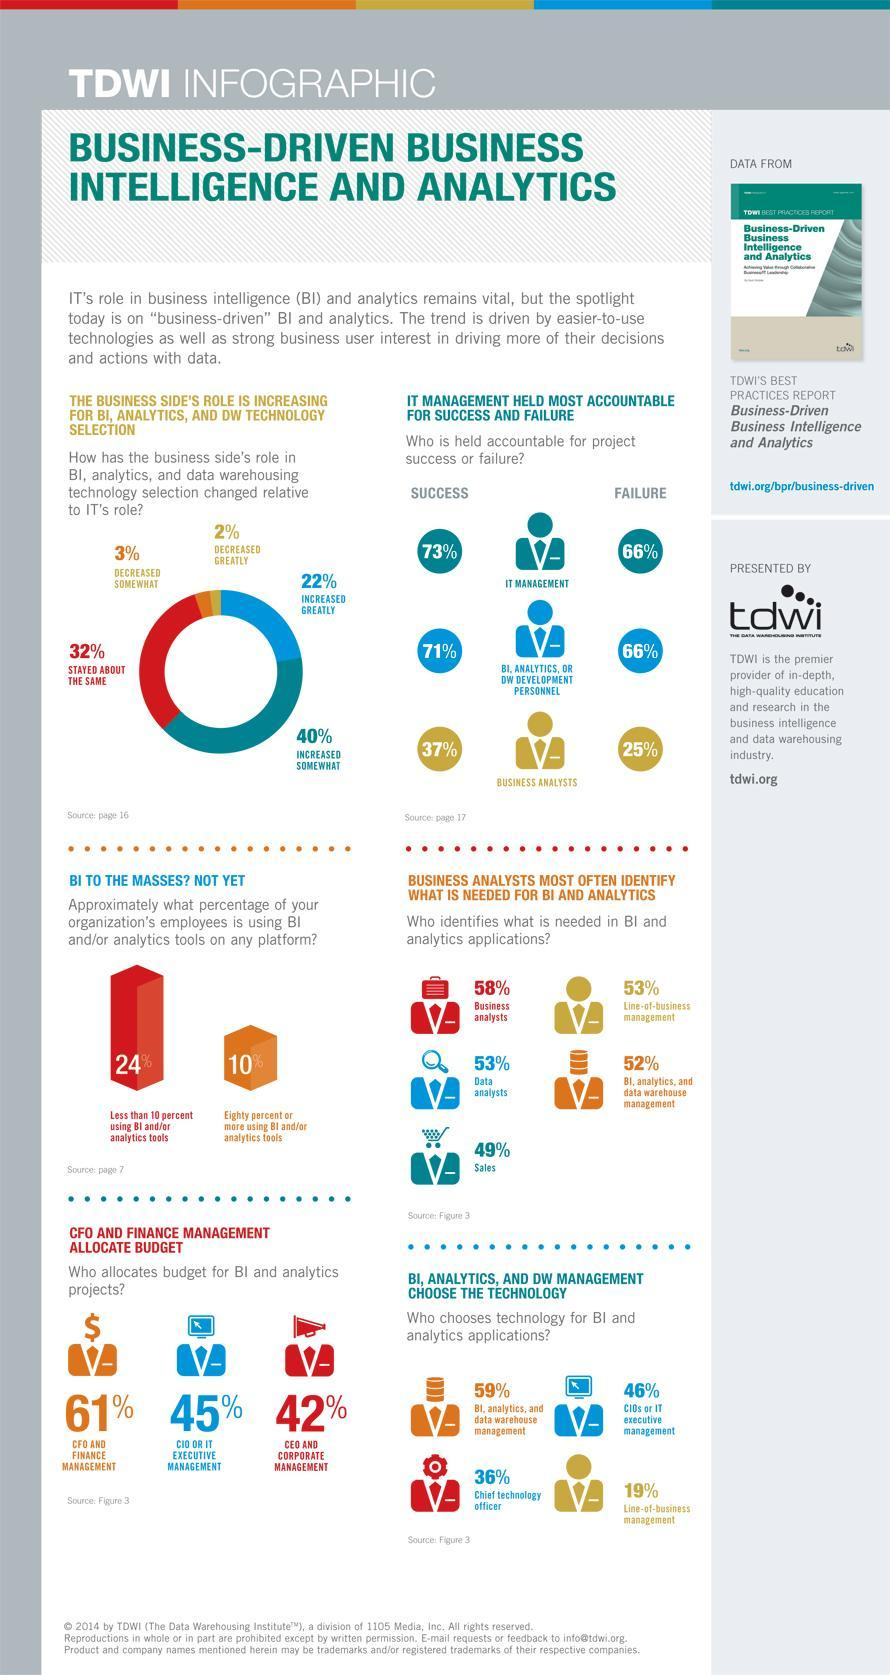What percentage of respondents feel that business plays a big role in comparison to IT in BI, Analytics, and Data warehousing ?
Answer the question with a short phrase. 22% What percentage of Chief Information Officers play a role in allocating budget  for BI and analytics in percentage, 61%, 45%, or  42%? 45% What is the accountability percentage shared by IT management and DW development personnel for project failures? 66% What percentage of respondents feel that business has bare minimum role to play in comparison to IT in BI, Analytics, and Data warehousing ? 2% What percentage of business analysts identifies what is needed in BI, 52%, 53%, or 58%? 58% What percentage of DW Management chooses technology needed in BI and Analytics, 59%, 42%, or 46%? 59% 